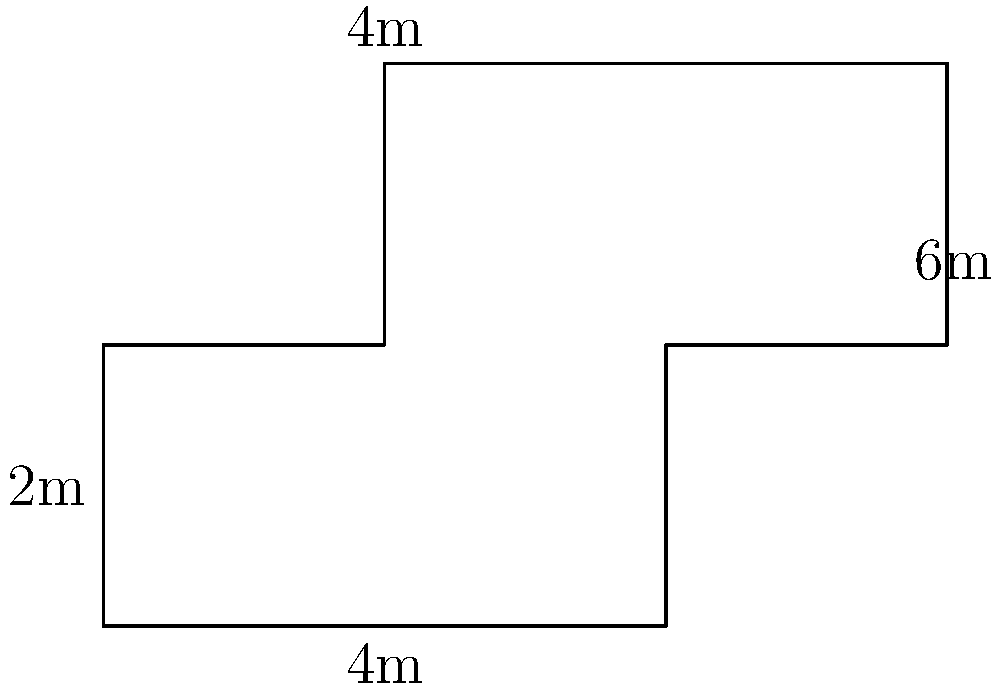As part of a community garden project, you're planning a cross-shaped garden plot. The garden's dimensions are shown in the diagram. What is the perimeter of this garden plot? To find the perimeter, we need to add up the lengths of all sides of the cross-shaped garden plot. Let's break it down step-by-step:

1) The garden consists of a central square with two rectangles extending from it.

2) The central square has sides of 2m each.

3) The horizontal rectangle extends 2m on each side of the central square, with a width of 2m.

4) The vertical rectangle extends 1m above and 1m below the central square, with a width of 2m.

5) Let's count the sides clockwise, starting from the bottom-left corner:
   - Bottom: 4m
   - Right side: 2m + 2m = 4m
   - Top right: 2m
   - Right of top extension: 2m
   - Top of top extension: 2m
   - Left of top extension: 2m
   - Top left: 2m
   - Left side: 2m + 2m = 4m

6) Adding all these lengths:
   $4m + 4m + 2m + 2m + 2m + 2m + 2m + 4m = 22m$

Therefore, the perimeter of the cross-shaped garden plot is 22 meters.
Answer: 22m 